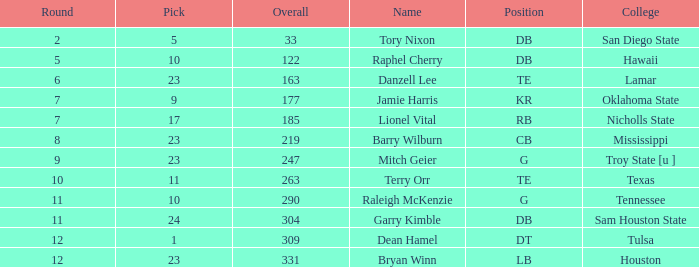Which Overall is the highest one that has a Name of raleigh mckenzie, and a Pick larger than 10? None. 